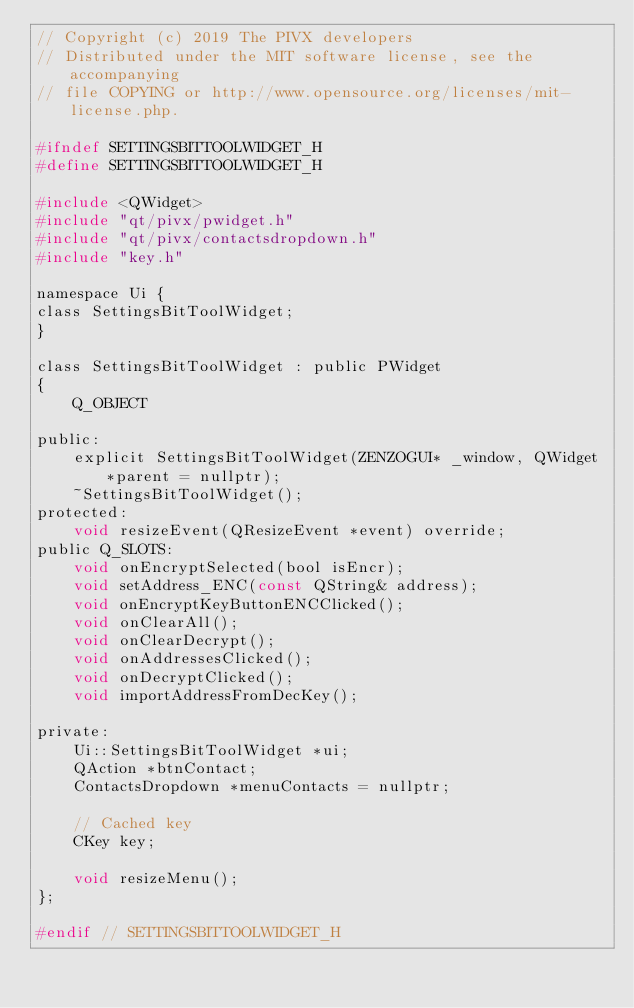<code> <loc_0><loc_0><loc_500><loc_500><_C_>// Copyright (c) 2019 The PIVX developers
// Distributed under the MIT software license, see the accompanying
// file COPYING or http://www.opensource.org/licenses/mit-license.php.

#ifndef SETTINGSBITTOOLWIDGET_H
#define SETTINGSBITTOOLWIDGET_H

#include <QWidget>
#include "qt/pivx/pwidget.h"
#include "qt/pivx/contactsdropdown.h"
#include "key.h"

namespace Ui {
class SettingsBitToolWidget;
}

class SettingsBitToolWidget : public PWidget
{
    Q_OBJECT

public:
    explicit SettingsBitToolWidget(ZENZOGUI* _window, QWidget *parent = nullptr);
    ~SettingsBitToolWidget();
protected:
    void resizeEvent(QResizeEvent *event) override;
public Q_SLOTS:
    void onEncryptSelected(bool isEncr);
    void setAddress_ENC(const QString& address);
    void onEncryptKeyButtonENCClicked();
    void onClearAll();
    void onClearDecrypt();
    void onAddressesClicked();
    void onDecryptClicked();
    void importAddressFromDecKey();

private:
    Ui::SettingsBitToolWidget *ui;
    QAction *btnContact;
    ContactsDropdown *menuContacts = nullptr;

    // Cached key
    CKey key;

    void resizeMenu();
};

#endif // SETTINGSBITTOOLWIDGET_H
</code> 